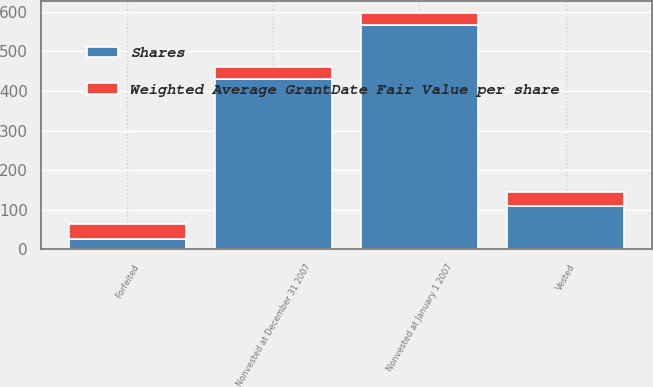Convert chart to OTSL. <chart><loc_0><loc_0><loc_500><loc_500><stacked_bar_chart><ecel><fcel>Nonvested at January 1 2007<fcel>Vested<fcel>Forfeited<fcel>Nonvested at December 31 2007<nl><fcel>Shares<fcel>566<fcel>110<fcel>25<fcel>431<nl><fcel>Weighted Average GrantDate Fair Value per share<fcel>31.97<fcel>36.08<fcel>39.89<fcel>30.46<nl></chart> 